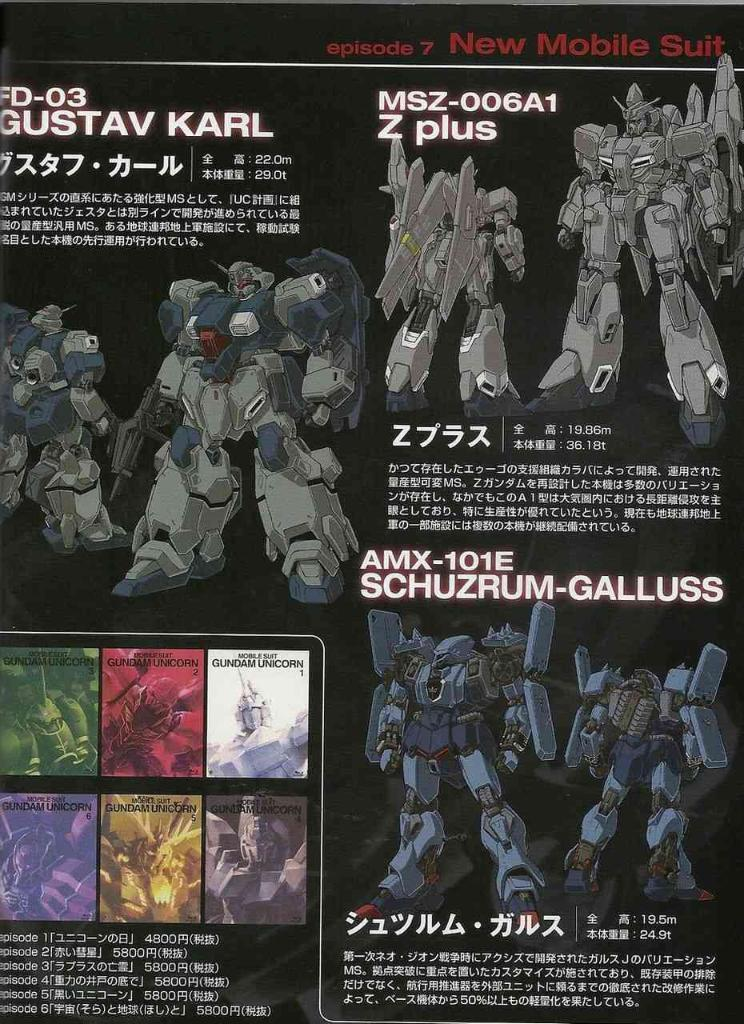<image>
Offer a succinct explanation of the picture presented. Action figures or characters are displayed including one with number MSZ-006A1. 